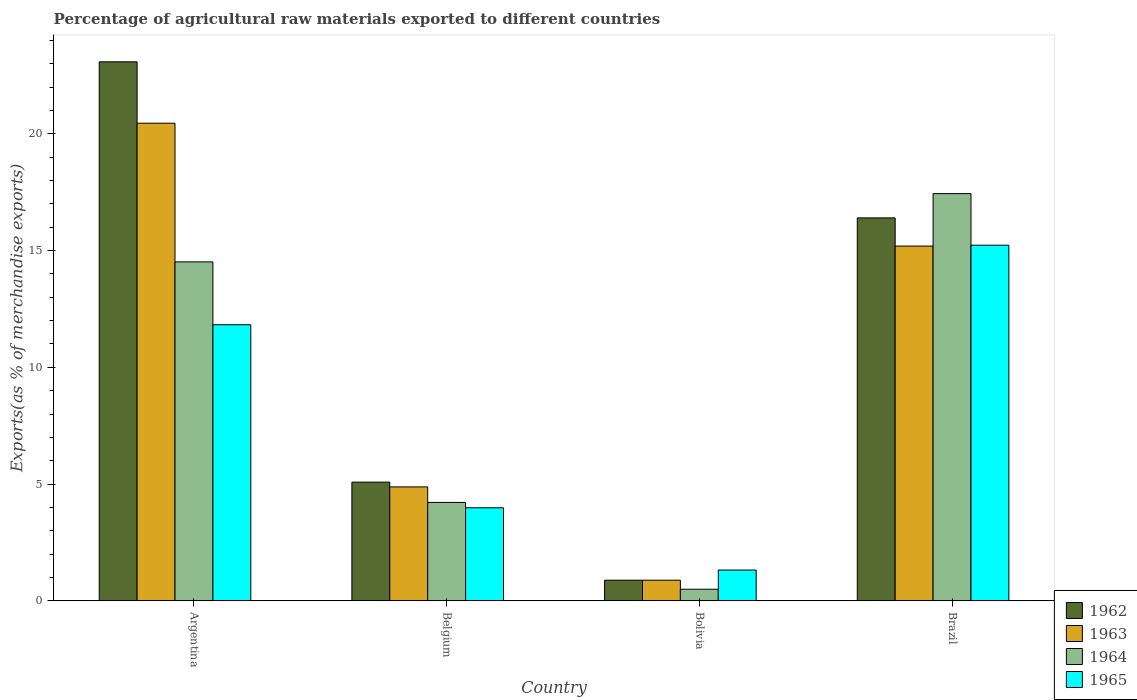How many bars are there on the 1st tick from the left?
Make the answer very short. 4. How many bars are there on the 1st tick from the right?
Ensure brevity in your answer.  4. What is the label of the 4th group of bars from the left?
Give a very brief answer. Brazil. What is the percentage of exports to different countries in 1963 in Brazil?
Your response must be concise. 15.2. Across all countries, what is the maximum percentage of exports to different countries in 1964?
Your response must be concise. 17.44. Across all countries, what is the minimum percentage of exports to different countries in 1964?
Provide a succinct answer. 0.49. In which country was the percentage of exports to different countries in 1962 maximum?
Provide a succinct answer. Argentina. In which country was the percentage of exports to different countries in 1964 minimum?
Keep it short and to the point. Bolivia. What is the total percentage of exports to different countries in 1965 in the graph?
Your response must be concise. 32.36. What is the difference between the percentage of exports to different countries in 1962 in Belgium and that in Brazil?
Your answer should be very brief. -11.32. What is the difference between the percentage of exports to different countries in 1963 in Belgium and the percentage of exports to different countries in 1964 in Brazil?
Your answer should be compact. -12.56. What is the average percentage of exports to different countries in 1964 per country?
Provide a short and direct response. 9.17. What is the difference between the percentage of exports to different countries of/in 1965 and percentage of exports to different countries of/in 1964 in Bolivia?
Your answer should be very brief. 0.82. What is the ratio of the percentage of exports to different countries in 1965 in Belgium to that in Brazil?
Provide a succinct answer. 0.26. Is the percentage of exports to different countries in 1963 in Belgium less than that in Bolivia?
Keep it short and to the point. No. Is the difference between the percentage of exports to different countries in 1965 in Belgium and Brazil greater than the difference between the percentage of exports to different countries in 1964 in Belgium and Brazil?
Keep it short and to the point. Yes. What is the difference between the highest and the second highest percentage of exports to different countries in 1964?
Make the answer very short. 13.23. What is the difference between the highest and the lowest percentage of exports to different countries in 1964?
Provide a short and direct response. 16.95. In how many countries, is the percentage of exports to different countries in 1964 greater than the average percentage of exports to different countries in 1964 taken over all countries?
Give a very brief answer. 2. Is the sum of the percentage of exports to different countries in 1964 in Belgium and Bolivia greater than the maximum percentage of exports to different countries in 1963 across all countries?
Ensure brevity in your answer.  No. What does the 3rd bar from the left in Brazil represents?
Your response must be concise. 1964. What does the 2nd bar from the right in Belgium represents?
Offer a very short reply. 1964. Is it the case that in every country, the sum of the percentage of exports to different countries in 1962 and percentage of exports to different countries in 1964 is greater than the percentage of exports to different countries in 1963?
Provide a short and direct response. Yes. Are all the bars in the graph horizontal?
Provide a short and direct response. No. What is the difference between two consecutive major ticks on the Y-axis?
Your answer should be very brief. 5. Are the values on the major ticks of Y-axis written in scientific E-notation?
Give a very brief answer. No. Does the graph contain any zero values?
Offer a very short reply. No. How many legend labels are there?
Your answer should be compact. 4. What is the title of the graph?
Ensure brevity in your answer.  Percentage of agricultural raw materials exported to different countries. What is the label or title of the Y-axis?
Provide a short and direct response. Exports(as % of merchandise exports). What is the Exports(as % of merchandise exports) of 1962 in Argentina?
Make the answer very short. 23.09. What is the Exports(as % of merchandise exports) of 1963 in Argentina?
Make the answer very short. 20.46. What is the Exports(as % of merchandise exports) in 1964 in Argentina?
Ensure brevity in your answer.  14.52. What is the Exports(as % of merchandise exports) of 1965 in Argentina?
Keep it short and to the point. 11.82. What is the Exports(as % of merchandise exports) in 1962 in Belgium?
Offer a very short reply. 5.08. What is the Exports(as % of merchandise exports) in 1963 in Belgium?
Your answer should be compact. 4.88. What is the Exports(as % of merchandise exports) in 1964 in Belgium?
Provide a short and direct response. 4.21. What is the Exports(as % of merchandise exports) of 1965 in Belgium?
Provide a succinct answer. 3.98. What is the Exports(as % of merchandise exports) of 1962 in Bolivia?
Your response must be concise. 0.88. What is the Exports(as % of merchandise exports) of 1963 in Bolivia?
Offer a very short reply. 0.88. What is the Exports(as % of merchandise exports) of 1964 in Bolivia?
Provide a short and direct response. 0.49. What is the Exports(as % of merchandise exports) in 1965 in Bolivia?
Make the answer very short. 1.32. What is the Exports(as % of merchandise exports) of 1962 in Brazil?
Your answer should be very brief. 16.4. What is the Exports(as % of merchandise exports) in 1963 in Brazil?
Offer a very short reply. 15.2. What is the Exports(as % of merchandise exports) in 1964 in Brazil?
Keep it short and to the point. 17.44. What is the Exports(as % of merchandise exports) of 1965 in Brazil?
Keep it short and to the point. 15.23. Across all countries, what is the maximum Exports(as % of merchandise exports) in 1962?
Provide a short and direct response. 23.09. Across all countries, what is the maximum Exports(as % of merchandise exports) in 1963?
Ensure brevity in your answer.  20.46. Across all countries, what is the maximum Exports(as % of merchandise exports) of 1964?
Give a very brief answer. 17.44. Across all countries, what is the maximum Exports(as % of merchandise exports) of 1965?
Offer a terse response. 15.23. Across all countries, what is the minimum Exports(as % of merchandise exports) in 1962?
Make the answer very short. 0.88. Across all countries, what is the minimum Exports(as % of merchandise exports) of 1963?
Provide a short and direct response. 0.88. Across all countries, what is the minimum Exports(as % of merchandise exports) in 1964?
Provide a succinct answer. 0.49. Across all countries, what is the minimum Exports(as % of merchandise exports) of 1965?
Your answer should be very brief. 1.32. What is the total Exports(as % of merchandise exports) in 1962 in the graph?
Give a very brief answer. 45.45. What is the total Exports(as % of merchandise exports) of 1963 in the graph?
Offer a terse response. 41.41. What is the total Exports(as % of merchandise exports) in 1964 in the graph?
Your answer should be very brief. 36.67. What is the total Exports(as % of merchandise exports) of 1965 in the graph?
Give a very brief answer. 32.36. What is the difference between the Exports(as % of merchandise exports) in 1962 in Argentina and that in Belgium?
Your answer should be very brief. 18.01. What is the difference between the Exports(as % of merchandise exports) in 1963 in Argentina and that in Belgium?
Provide a short and direct response. 15.58. What is the difference between the Exports(as % of merchandise exports) of 1964 in Argentina and that in Belgium?
Provide a short and direct response. 10.3. What is the difference between the Exports(as % of merchandise exports) in 1965 in Argentina and that in Belgium?
Ensure brevity in your answer.  7.84. What is the difference between the Exports(as % of merchandise exports) in 1962 in Argentina and that in Bolivia?
Provide a succinct answer. 22.21. What is the difference between the Exports(as % of merchandise exports) of 1963 in Argentina and that in Bolivia?
Give a very brief answer. 19.58. What is the difference between the Exports(as % of merchandise exports) in 1964 in Argentina and that in Bolivia?
Your answer should be compact. 14.02. What is the difference between the Exports(as % of merchandise exports) in 1965 in Argentina and that in Bolivia?
Your response must be concise. 10.51. What is the difference between the Exports(as % of merchandise exports) in 1962 in Argentina and that in Brazil?
Offer a terse response. 6.69. What is the difference between the Exports(as % of merchandise exports) in 1963 in Argentina and that in Brazil?
Your response must be concise. 5.26. What is the difference between the Exports(as % of merchandise exports) of 1964 in Argentina and that in Brazil?
Your response must be concise. -2.93. What is the difference between the Exports(as % of merchandise exports) of 1965 in Argentina and that in Brazil?
Make the answer very short. -3.41. What is the difference between the Exports(as % of merchandise exports) of 1962 in Belgium and that in Bolivia?
Your answer should be very brief. 4.2. What is the difference between the Exports(as % of merchandise exports) of 1963 in Belgium and that in Bolivia?
Keep it short and to the point. 4. What is the difference between the Exports(as % of merchandise exports) in 1964 in Belgium and that in Bolivia?
Make the answer very short. 3.72. What is the difference between the Exports(as % of merchandise exports) in 1965 in Belgium and that in Bolivia?
Make the answer very short. 2.67. What is the difference between the Exports(as % of merchandise exports) in 1962 in Belgium and that in Brazil?
Offer a terse response. -11.32. What is the difference between the Exports(as % of merchandise exports) in 1963 in Belgium and that in Brazil?
Your answer should be very brief. -10.32. What is the difference between the Exports(as % of merchandise exports) of 1964 in Belgium and that in Brazil?
Your answer should be compact. -13.23. What is the difference between the Exports(as % of merchandise exports) of 1965 in Belgium and that in Brazil?
Ensure brevity in your answer.  -11.25. What is the difference between the Exports(as % of merchandise exports) in 1962 in Bolivia and that in Brazil?
Make the answer very short. -15.52. What is the difference between the Exports(as % of merchandise exports) of 1963 in Bolivia and that in Brazil?
Offer a terse response. -14.31. What is the difference between the Exports(as % of merchandise exports) of 1964 in Bolivia and that in Brazil?
Ensure brevity in your answer.  -16.95. What is the difference between the Exports(as % of merchandise exports) in 1965 in Bolivia and that in Brazil?
Provide a succinct answer. -13.92. What is the difference between the Exports(as % of merchandise exports) in 1962 in Argentina and the Exports(as % of merchandise exports) in 1963 in Belgium?
Ensure brevity in your answer.  18.21. What is the difference between the Exports(as % of merchandise exports) of 1962 in Argentina and the Exports(as % of merchandise exports) of 1964 in Belgium?
Offer a very short reply. 18.87. What is the difference between the Exports(as % of merchandise exports) of 1962 in Argentina and the Exports(as % of merchandise exports) of 1965 in Belgium?
Your answer should be very brief. 19.1. What is the difference between the Exports(as % of merchandise exports) of 1963 in Argentina and the Exports(as % of merchandise exports) of 1964 in Belgium?
Your answer should be very brief. 16.25. What is the difference between the Exports(as % of merchandise exports) in 1963 in Argentina and the Exports(as % of merchandise exports) in 1965 in Belgium?
Your answer should be compact. 16.48. What is the difference between the Exports(as % of merchandise exports) in 1964 in Argentina and the Exports(as % of merchandise exports) in 1965 in Belgium?
Offer a terse response. 10.53. What is the difference between the Exports(as % of merchandise exports) in 1962 in Argentina and the Exports(as % of merchandise exports) in 1963 in Bolivia?
Your answer should be compact. 22.21. What is the difference between the Exports(as % of merchandise exports) of 1962 in Argentina and the Exports(as % of merchandise exports) of 1964 in Bolivia?
Give a very brief answer. 22.59. What is the difference between the Exports(as % of merchandise exports) in 1962 in Argentina and the Exports(as % of merchandise exports) in 1965 in Bolivia?
Your answer should be compact. 21.77. What is the difference between the Exports(as % of merchandise exports) in 1963 in Argentina and the Exports(as % of merchandise exports) in 1964 in Bolivia?
Give a very brief answer. 19.96. What is the difference between the Exports(as % of merchandise exports) of 1963 in Argentina and the Exports(as % of merchandise exports) of 1965 in Bolivia?
Provide a short and direct response. 19.14. What is the difference between the Exports(as % of merchandise exports) of 1964 in Argentina and the Exports(as % of merchandise exports) of 1965 in Bolivia?
Your response must be concise. 13.2. What is the difference between the Exports(as % of merchandise exports) of 1962 in Argentina and the Exports(as % of merchandise exports) of 1963 in Brazil?
Provide a short and direct response. 7.89. What is the difference between the Exports(as % of merchandise exports) in 1962 in Argentina and the Exports(as % of merchandise exports) in 1964 in Brazil?
Your answer should be compact. 5.65. What is the difference between the Exports(as % of merchandise exports) in 1962 in Argentina and the Exports(as % of merchandise exports) in 1965 in Brazil?
Make the answer very short. 7.86. What is the difference between the Exports(as % of merchandise exports) of 1963 in Argentina and the Exports(as % of merchandise exports) of 1964 in Brazil?
Offer a very short reply. 3.02. What is the difference between the Exports(as % of merchandise exports) of 1963 in Argentina and the Exports(as % of merchandise exports) of 1965 in Brazil?
Give a very brief answer. 5.23. What is the difference between the Exports(as % of merchandise exports) of 1964 in Argentina and the Exports(as % of merchandise exports) of 1965 in Brazil?
Make the answer very short. -0.72. What is the difference between the Exports(as % of merchandise exports) of 1962 in Belgium and the Exports(as % of merchandise exports) of 1963 in Bolivia?
Give a very brief answer. 4.2. What is the difference between the Exports(as % of merchandise exports) in 1962 in Belgium and the Exports(as % of merchandise exports) in 1964 in Bolivia?
Keep it short and to the point. 4.59. What is the difference between the Exports(as % of merchandise exports) in 1962 in Belgium and the Exports(as % of merchandise exports) in 1965 in Bolivia?
Offer a very short reply. 3.77. What is the difference between the Exports(as % of merchandise exports) of 1963 in Belgium and the Exports(as % of merchandise exports) of 1964 in Bolivia?
Offer a terse response. 4.38. What is the difference between the Exports(as % of merchandise exports) of 1963 in Belgium and the Exports(as % of merchandise exports) of 1965 in Bolivia?
Offer a very short reply. 3.56. What is the difference between the Exports(as % of merchandise exports) in 1964 in Belgium and the Exports(as % of merchandise exports) in 1965 in Bolivia?
Offer a very short reply. 2.9. What is the difference between the Exports(as % of merchandise exports) in 1962 in Belgium and the Exports(as % of merchandise exports) in 1963 in Brazil?
Offer a very short reply. -10.11. What is the difference between the Exports(as % of merchandise exports) in 1962 in Belgium and the Exports(as % of merchandise exports) in 1964 in Brazil?
Your response must be concise. -12.36. What is the difference between the Exports(as % of merchandise exports) in 1962 in Belgium and the Exports(as % of merchandise exports) in 1965 in Brazil?
Keep it short and to the point. -10.15. What is the difference between the Exports(as % of merchandise exports) in 1963 in Belgium and the Exports(as % of merchandise exports) in 1964 in Brazil?
Ensure brevity in your answer.  -12.56. What is the difference between the Exports(as % of merchandise exports) of 1963 in Belgium and the Exports(as % of merchandise exports) of 1965 in Brazil?
Ensure brevity in your answer.  -10.35. What is the difference between the Exports(as % of merchandise exports) in 1964 in Belgium and the Exports(as % of merchandise exports) in 1965 in Brazil?
Provide a short and direct response. -11.02. What is the difference between the Exports(as % of merchandise exports) in 1962 in Bolivia and the Exports(as % of merchandise exports) in 1963 in Brazil?
Your response must be concise. -14.31. What is the difference between the Exports(as % of merchandise exports) in 1962 in Bolivia and the Exports(as % of merchandise exports) in 1964 in Brazil?
Provide a succinct answer. -16.56. What is the difference between the Exports(as % of merchandise exports) in 1962 in Bolivia and the Exports(as % of merchandise exports) in 1965 in Brazil?
Give a very brief answer. -14.35. What is the difference between the Exports(as % of merchandise exports) in 1963 in Bolivia and the Exports(as % of merchandise exports) in 1964 in Brazil?
Make the answer very short. -16.56. What is the difference between the Exports(as % of merchandise exports) of 1963 in Bolivia and the Exports(as % of merchandise exports) of 1965 in Brazil?
Provide a succinct answer. -14.35. What is the difference between the Exports(as % of merchandise exports) in 1964 in Bolivia and the Exports(as % of merchandise exports) in 1965 in Brazil?
Your answer should be very brief. -14.74. What is the average Exports(as % of merchandise exports) in 1962 per country?
Ensure brevity in your answer.  11.36. What is the average Exports(as % of merchandise exports) of 1963 per country?
Your answer should be very brief. 10.35. What is the average Exports(as % of merchandise exports) in 1964 per country?
Your answer should be very brief. 9.17. What is the average Exports(as % of merchandise exports) of 1965 per country?
Provide a succinct answer. 8.09. What is the difference between the Exports(as % of merchandise exports) of 1962 and Exports(as % of merchandise exports) of 1963 in Argentina?
Your response must be concise. 2.63. What is the difference between the Exports(as % of merchandise exports) of 1962 and Exports(as % of merchandise exports) of 1964 in Argentina?
Give a very brief answer. 8.57. What is the difference between the Exports(as % of merchandise exports) of 1962 and Exports(as % of merchandise exports) of 1965 in Argentina?
Your response must be concise. 11.26. What is the difference between the Exports(as % of merchandise exports) in 1963 and Exports(as % of merchandise exports) in 1964 in Argentina?
Your answer should be very brief. 5.94. What is the difference between the Exports(as % of merchandise exports) in 1963 and Exports(as % of merchandise exports) in 1965 in Argentina?
Offer a very short reply. 8.63. What is the difference between the Exports(as % of merchandise exports) of 1964 and Exports(as % of merchandise exports) of 1965 in Argentina?
Provide a succinct answer. 2.69. What is the difference between the Exports(as % of merchandise exports) in 1962 and Exports(as % of merchandise exports) in 1963 in Belgium?
Offer a terse response. 0.2. What is the difference between the Exports(as % of merchandise exports) of 1962 and Exports(as % of merchandise exports) of 1964 in Belgium?
Provide a succinct answer. 0.87. What is the difference between the Exports(as % of merchandise exports) of 1962 and Exports(as % of merchandise exports) of 1965 in Belgium?
Ensure brevity in your answer.  1.1. What is the difference between the Exports(as % of merchandise exports) in 1963 and Exports(as % of merchandise exports) in 1964 in Belgium?
Keep it short and to the point. 0.66. What is the difference between the Exports(as % of merchandise exports) in 1963 and Exports(as % of merchandise exports) in 1965 in Belgium?
Your answer should be very brief. 0.89. What is the difference between the Exports(as % of merchandise exports) of 1964 and Exports(as % of merchandise exports) of 1965 in Belgium?
Your answer should be very brief. 0.23. What is the difference between the Exports(as % of merchandise exports) in 1962 and Exports(as % of merchandise exports) in 1963 in Bolivia?
Give a very brief answer. 0. What is the difference between the Exports(as % of merchandise exports) of 1962 and Exports(as % of merchandise exports) of 1964 in Bolivia?
Give a very brief answer. 0.39. What is the difference between the Exports(as % of merchandise exports) of 1962 and Exports(as % of merchandise exports) of 1965 in Bolivia?
Your answer should be compact. -0.43. What is the difference between the Exports(as % of merchandise exports) of 1963 and Exports(as % of merchandise exports) of 1964 in Bolivia?
Offer a very short reply. 0.39. What is the difference between the Exports(as % of merchandise exports) in 1963 and Exports(as % of merchandise exports) in 1965 in Bolivia?
Your response must be concise. -0.43. What is the difference between the Exports(as % of merchandise exports) of 1964 and Exports(as % of merchandise exports) of 1965 in Bolivia?
Provide a succinct answer. -0.82. What is the difference between the Exports(as % of merchandise exports) in 1962 and Exports(as % of merchandise exports) in 1963 in Brazil?
Provide a short and direct response. 1.21. What is the difference between the Exports(as % of merchandise exports) in 1962 and Exports(as % of merchandise exports) in 1964 in Brazil?
Your response must be concise. -1.04. What is the difference between the Exports(as % of merchandise exports) of 1962 and Exports(as % of merchandise exports) of 1965 in Brazil?
Offer a very short reply. 1.17. What is the difference between the Exports(as % of merchandise exports) in 1963 and Exports(as % of merchandise exports) in 1964 in Brazil?
Offer a very short reply. -2.25. What is the difference between the Exports(as % of merchandise exports) in 1963 and Exports(as % of merchandise exports) in 1965 in Brazil?
Ensure brevity in your answer.  -0.04. What is the difference between the Exports(as % of merchandise exports) of 1964 and Exports(as % of merchandise exports) of 1965 in Brazil?
Your response must be concise. 2.21. What is the ratio of the Exports(as % of merchandise exports) in 1962 in Argentina to that in Belgium?
Offer a very short reply. 4.54. What is the ratio of the Exports(as % of merchandise exports) in 1963 in Argentina to that in Belgium?
Provide a succinct answer. 4.19. What is the ratio of the Exports(as % of merchandise exports) in 1964 in Argentina to that in Belgium?
Provide a short and direct response. 3.45. What is the ratio of the Exports(as % of merchandise exports) of 1965 in Argentina to that in Belgium?
Give a very brief answer. 2.97. What is the ratio of the Exports(as % of merchandise exports) of 1962 in Argentina to that in Bolivia?
Give a very brief answer. 26.19. What is the ratio of the Exports(as % of merchandise exports) of 1963 in Argentina to that in Bolivia?
Offer a very short reply. 23.21. What is the ratio of the Exports(as % of merchandise exports) of 1964 in Argentina to that in Bolivia?
Provide a succinct answer. 29.36. What is the ratio of the Exports(as % of merchandise exports) of 1965 in Argentina to that in Bolivia?
Provide a succinct answer. 8.98. What is the ratio of the Exports(as % of merchandise exports) in 1962 in Argentina to that in Brazil?
Provide a succinct answer. 1.41. What is the ratio of the Exports(as % of merchandise exports) of 1963 in Argentina to that in Brazil?
Offer a very short reply. 1.35. What is the ratio of the Exports(as % of merchandise exports) of 1964 in Argentina to that in Brazil?
Give a very brief answer. 0.83. What is the ratio of the Exports(as % of merchandise exports) of 1965 in Argentina to that in Brazil?
Your answer should be very brief. 0.78. What is the ratio of the Exports(as % of merchandise exports) of 1962 in Belgium to that in Bolivia?
Your answer should be compact. 5.77. What is the ratio of the Exports(as % of merchandise exports) in 1963 in Belgium to that in Bolivia?
Keep it short and to the point. 5.53. What is the ratio of the Exports(as % of merchandise exports) of 1964 in Belgium to that in Bolivia?
Provide a succinct answer. 8.52. What is the ratio of the Exports(as % of merchandise exports) in 1965 in Belgium to that in Bolivia?
Offer a terse response. 3.03. What is the ratio of the Exports(as % of merchandise exports) in 1962 in Belgium to that in Brazil?
Keep it short and to the point. 0.31. What is the ratio of the Exports(as % of merchandise exports) in 1963 in Belgium to that in Brazil?
Provide a succinct answer. 0.32. What is the ratio of the Exports(as % of merchandise exports) in 1964 in Belgium to that in Brazil?
Provide a short and direct response. 0.24. What is the ratio of the Exports(as % of merchandise exports) of 1965 in Belgium to that in Brazil?
Give a very brief answer. 0.26. What is the ratio of the Exports(as % of merchandise exports) of 1962 in Bolivia to that in Brazil?
Provide a succinct answer. 0.05. What is the ratio of the Exports(as % of merchandise exports) in 1963 in Bolivia to that in Brazil?
Your response must be concise. 0.06. What is the ratio of the Exports(as % of merchandise exports) in 1964 in Bolivia to that in Brazil?
Your answer should be very brief. 0.03. What is the ratio of the Exports(as % of merchandise exports) in 1965 in Bolivia to that in Brazil?
Ensure brevity in your answer.  0.09. What is the difference between the highest and the second highest Exports(as % of merchandise exports) of 1962?
Offer a terse response. 6.69. What is the difference between the highest and the second highest Exports(as % of merchandise exports) of 1963?
Ensure brevity in your answer.  5.26. What is the difference between the highest and the second highest Exports(as % of merchandise exports) in 1964?
Your answer should be compact. 2.93. What is the difference between the highest and the second highest Exports(as % of merchandise exports) in 1965?
Provide a short and direct response. 3.41. What is the difference between the highest and the lowest Exports(as % of merchandise exports) in 1962?
Keep it short and to the point. 22.21. What is the difference between the highest and the lowest Exports(as % of merchandise exports) in 1963?
Make the answer very short. 19.58. What is the difference between the highest and the lowest Exports(as % of merchandise exports) of 1964?
Provide a succinct answer. 16.95. What is the difference between the highest and the lowest Exports(as % of merchandise exports) of 1965?
Make the answer very short. 13.92. 